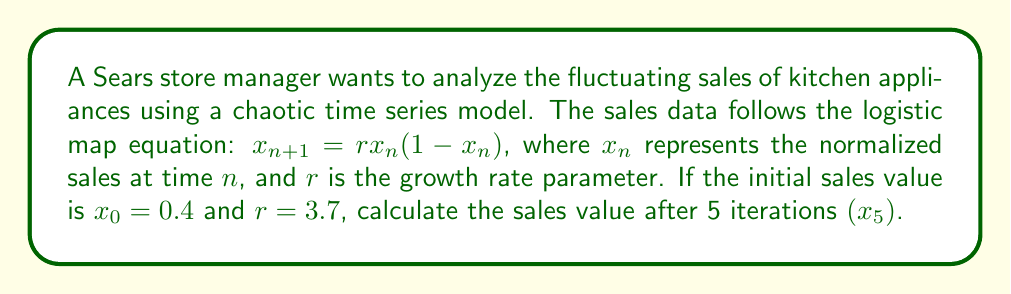Can you solve this math problem? To solve this problem, we need to iterate the logistic map equation 5 times:

1. For $n = 0$:
   $x_1 = 3.7 \cdot 0.4 \cdot (1-0.4) = 3.7 \cdot 0.4 \cdot 0.6 = 0.888$

2. For $n = 1$:
   $x_2 = 3.7 \cdot 0.888 \cdot (1-0.888) = 3.7 \cdot 0.888 \cdot 0.112 = 0.368$

3. For $n = 2$:
   $x_3 = 3.7 \cdot 0.368 \cdot (1-0.368) = 3.7 \cdot 0.368 \cdot 0.632 = 0.862$

4. For $n = 3$:
   $x_4 = 3.7 \cdot 0.862 \cdot (1-0.862) = 3.7 \cdot 0.862 \cdot 0.138 = 0.440$

5. For $n = 4$:
   $x_5 = 3.7 \cdot 0.440 \cdot (1-0.440) = 3.7 \cdot 0.440 \cdot 0.560 = 0.912$

Therefore, after 5 iterations, the sales value $x_5$ is approximately 0.912.
Answer: 0.912 